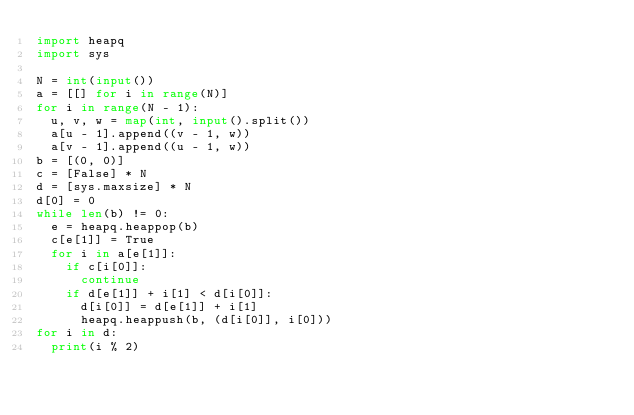<code> <loc_0><loc_0><loc_500><loc_500><_Python_>import heapq
import sys

N = int(input())
a = [[] for i in range(N)]
for i in range(N - 1):
	u, v, w = map(int, input().split())
	a[u - 1].append((v - 1, w))
	a[v - 1].append((u - 1, w))
b = [(0, 0)]
c = [False] * N
d = [sys.maxsize] * N
d[0] = 0
while len(b) != 0:
	e = heapq.heappop(b)
	c[e[1]] = True
	for i in a[e[1]]:
		if c[i[0]]:
			continue
		if d[e[1]] + i[1] < d[i[0]]:
			d[i[0]] = d[e[1]] + i[1]
			heapq.heappush(b, (d[i[0]], i[0]))
for i in d:
	print(i % 2)</code> 